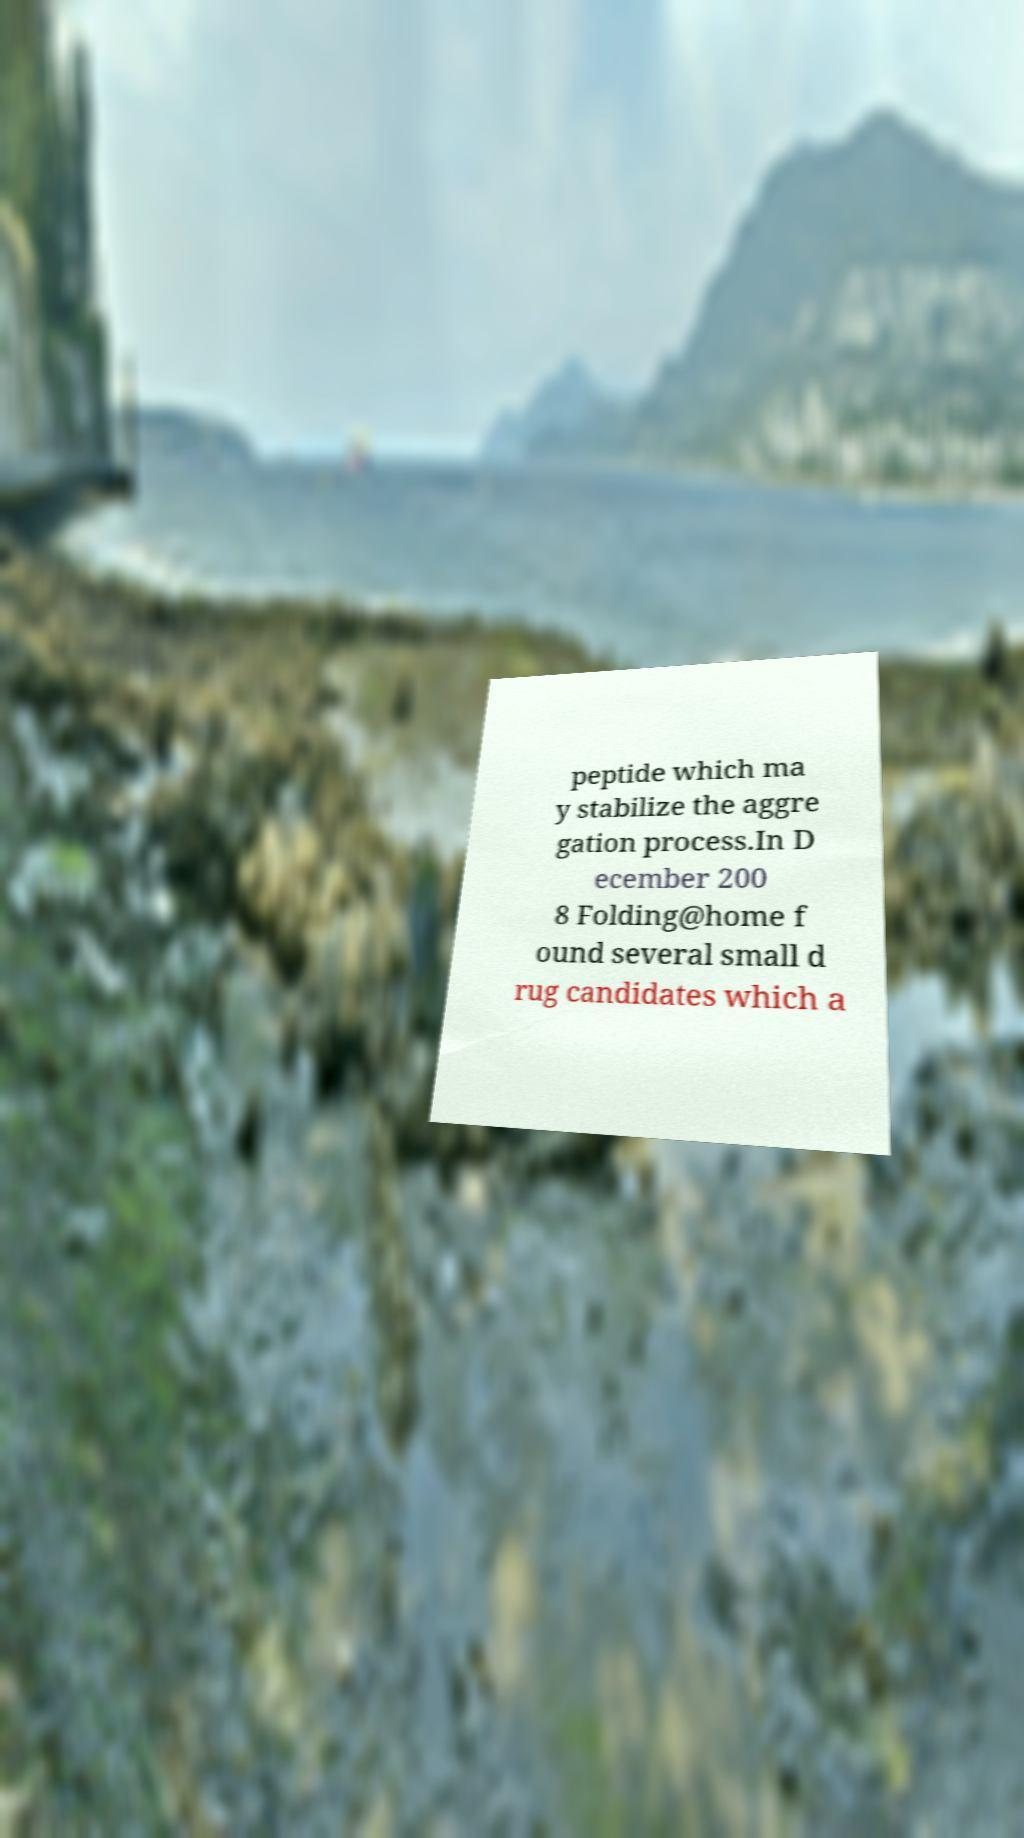I need the written content from this picture converted into text. Can you do that? peptide which ma y stabilize the aggre gation process.In D ecember 200 8 Folding@home f ound several small d rug candidates which a 